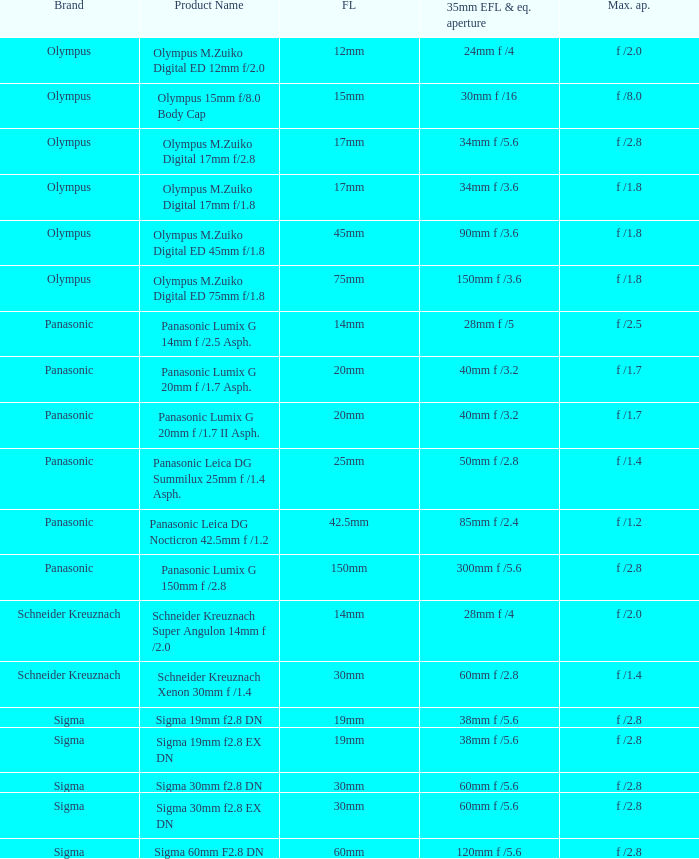Give me the full table as a dictionary. {'header': ['Brand', 'Product Name', 'FL', '35mm EFL & eq. aperture', 'Max. ap.'], 'rows': [['Olympus', 'Olympus M.Zuiko Digital ED 12mm f/2.0', '12mm', '24mm f /4', 'f /2.0'], ['Olympus', 'Olympus 15mm f/8.0 Body Cap', '15mm', '30mm f /16', 'f /8.0'], ['Olympus', 'Olympus M.Zuiko Digital 17mm f/2.8', '17mm', '34mm f /5.6', 'f /2.8'], ['Olympus', 'Olympus M.Zuiko Digital 17mm f/1.8', '17mm', '34mm f /3.6', 'f /1.8'], ['Olympus', 'Olympus M.Zuiko Digital ED 45mm f/1.8', '45mm', '90mm f /3.6', 'f /1.8'], ['Olympus', 'Olympus M.Zuiko Digital ED 75mm f/1.8', '75mm', '150mm f /3.6', 'f /1.8'], ['Panasonic', 'Panasonic Lumix G 14mm f /2.5 Asph.', '14mm', '28mm f /5', 'f /2.5'], ['Panasonic', 'Panasonic Lumix G 20mm f /1.7 Asph.', '20mm', '40mm f /3.2', 'f /1.7'], ['Panasonic', 'Panasonic Lumix G 20mm f /1.7 II Asph.', '20mm', '40mm f /3.2', 'f /1.7'], ['Panasonic', 'Panasonic Leica DG Summilux 25mm f /1.4 Asph.', '25mm', '50mm f /2.8', 'f /1.4'], ['Panasonic', 'Panasonic Leica DG Nocticron 42.5mm f /1.2', '42.5mm', '85mm f /2.4', 'f /1.2'], ['Panasonic', 'Panasonic Lumix G 150mm f /2.8', '150mm', '300mm f /5.6', 'f /2.8'], ['Schneider Kreuznach', 'Schneider Kreuznach Super Angulon 14mm f /2.0', '14mm', '28mm f /4', 'f /2.0'], ['Schneider Kreuznach', 'Schneider Kreuznach Xenon 30mm f /1.4', '30mm', '60mm f /2.8', 'f /1.4'], ['Sigma', 'Sigma 19mm f2.8 DN', '19mm', '38mm f /5.6', 'f /2.8'], ['Sigma', 'Sigma 19mm f2.8 EX DN', '19mm', '38mm f /5.6', 'f /2.8'], ['Sigma', 'Sigma 30mm f2.8 DN', '30mm', '60mm f /5.6', 'f /2.8'], ['Sigma', 'Sigma 30mm f2.8 EX DN', '30mm', '60mm f /5.6', 'f /2.8'], ['Sigma', 'Sigma 60mm F2.8 DN', '60mm', '120mm f /5.6', 'f /2.8']]} What is the maximum aperture of the lens(es) with a focal length of 20mm? F /1.7, f /1.7. 